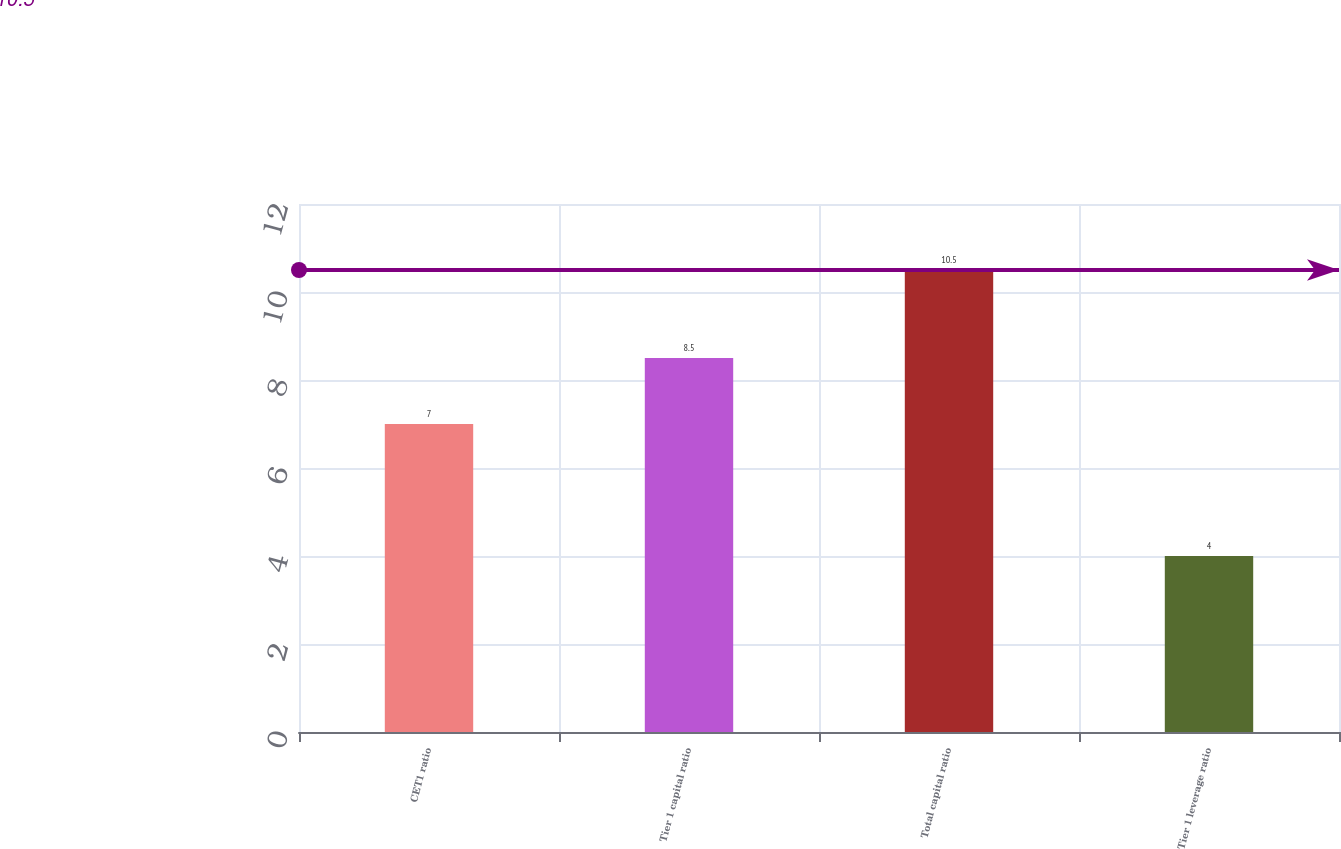Convert chart. <chart><loc_0><loc_0><loc_500><loc_500><bar_chart><fcel>CET1 ratio<fcel>Tier 1 capital ratio<fcel>Total capital ratio<fcel>Tier 1 leverage ratio<nl><fcel>7<fcel>8.5<fcel>10.5<fcel>4<nl></chart> 